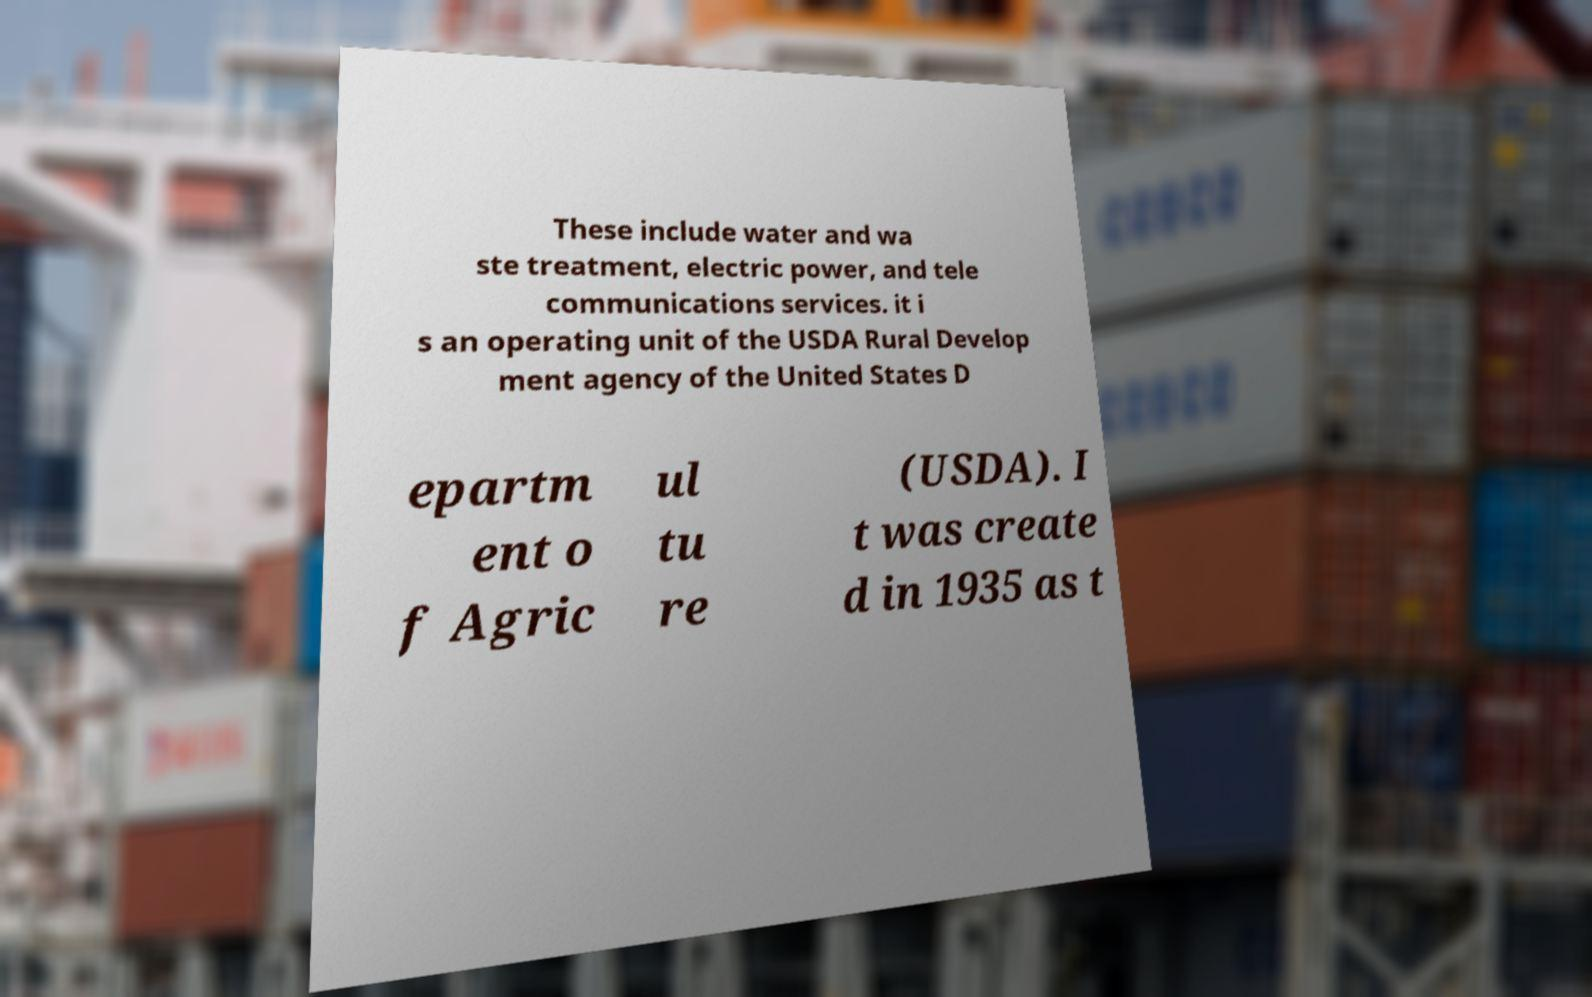Could you assist in decoding the text presented in this image and type it out clearly? These include water and wa ste treatment, electric power, and tele communications services. it i s an operating unit of the USDA Rural Develop ment agency of the United States D epartm ent o f Agric ul tu re (USDA). I t was create d in 1935 as t 